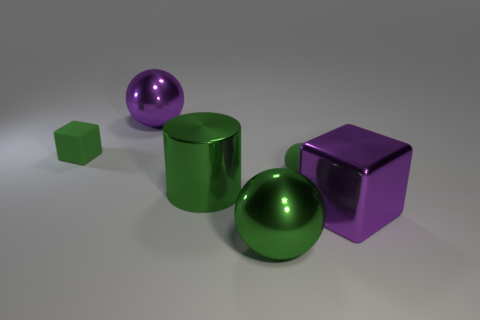Subtract all green rubber spheres. How many spheres are left? 2 Subtract all brown cylinders. How many green spheres are left? 2 Add 1 tiny cyan matte objects. How many objects exist? 7 Subtract all green blocks. How many blocks are left? 1 Subtract all cubes. How many objects are left? 4 Subtract all brown spheres. Subtract all blue cylinders. How many spheres are left? 3 Add 6 metal cubes. How many metal cubes are left? 7 Add 6 matte balls. How many matte balls exist? 7 Subtract 0 yellow cylinders. How many objects are left? 6 Subtract all big purple matte cylinders. Subtract all green objects. How many objects are left? 2 